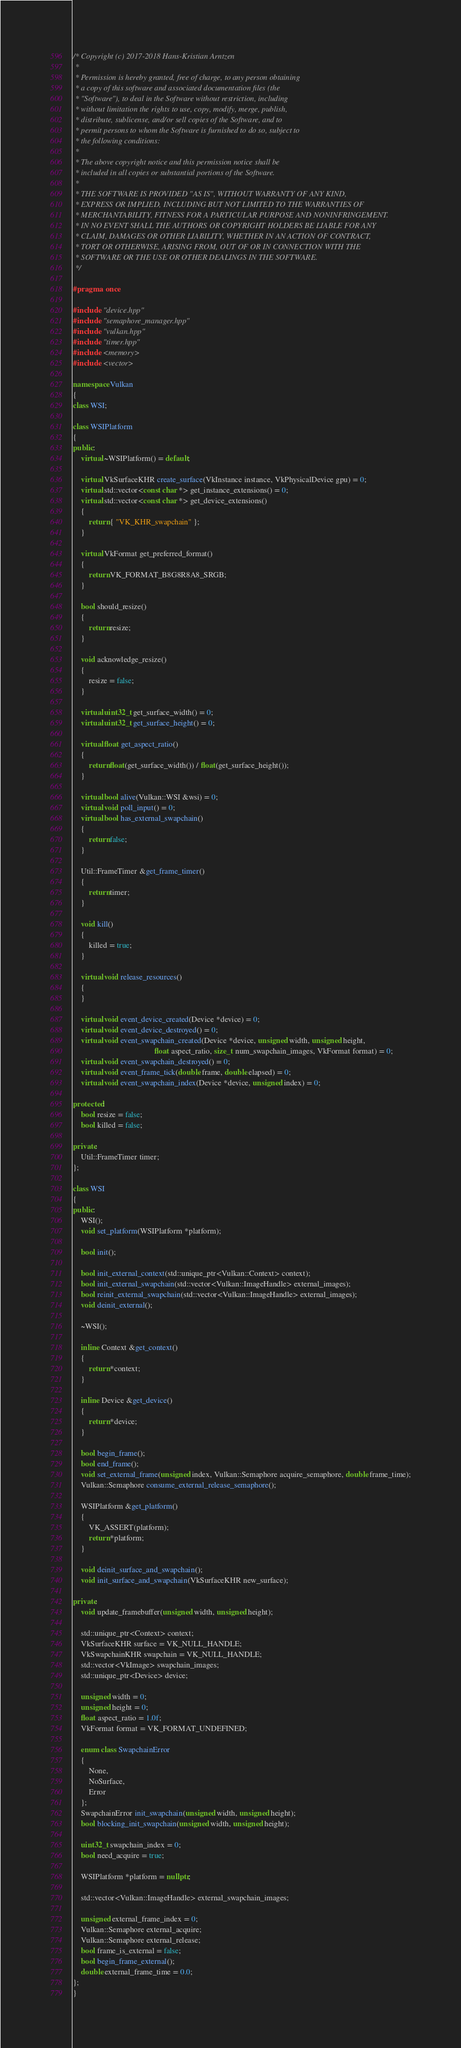<code> <loc_0><loc_0><loc_500><loc_500><_C++_>/* Copyright (c) 2017-2018 Hans-Kristian Arntzen
 *
 * Permission is hereby granted, free of charge, to any person obtaining
 * a copy of this software and associated documentation files (the
 * "Software"), to deal in the Software without restriction, including
 * without limitation the rights to use, copy, modify, merge, publish,
 * distribute, sublicense, and/or sell copies of the Software, and to
 * permit persons to whom the Software is furnished to do so, subject to
 * the following conditions:
 *
 * The above copyright notice and this permission notice shall be
 * included in all copies or substantial portions of the Software.
 *
 * THE SOFTWARE IS PROVIDED "AS IS", WITHOUT WARRANTY OF ANY KIND,
 * EXPRESS OR IMPLIED, INCLUDING BUT NOT LIMITED TO THE WARRANTIES OF
 * MERCHANTABILITY, FITNESS FOR A PARTICULAR PURPOSE AND NONINFRINGEMENT.
 * IN NO EVENT SHALL THE AUTHORS OR COPYRIGHT HOLDERS BE LIABLE FOR ANY
 * CLAIM, DAMAGES OR OTHER LIABILITY, WHETHER IN AN ACTION OF CONTRACT,
 * TORT OR OTHERWISE, ARISING FROM, OUT OF OR IN CONNECTION WITH THE
 * SOFTWARE OR THE USE OR OTHER DEALINGS IN THE SOFTWARE.
 */

#pragma once

#include "device.hpp"
#include "semaphore_manager.hpp"
#include "vulkan.hpp"
#include "timer.hpp"
#include <memory>
#include <vector>

namespace Vulkan
{
class WSI;

class WSIPlatform
{
public:
	virtual ~WSIPlatform() = default;

	virtual VkSurfaceKHR create_surface(VkInstance instance, VkPhysicalDevice gpu) = 0;
	virtual std::vector<const char *> get_instance_extensions() = 0;
	virtual std::vector<const char *> get_device_extensions()
	{
		return { "VK_KHR_swapchain" };
	}

	virtual VkFormat get_preferred_format()
	{
		return VK_FORMAT_B8G8R8A8_SRGB;
	}

	bool should_resize()
	{
		return resize;
	}

	void acknowledge_resize()
	{
		resize = false;
	}

	virtual uint32_t get_surface_width() = 0;
	virtual uint32_t get_surface_height() = 0;

	virtual float get_aspect_ratio()
	{
		return float(get_surface_width()) / float(get_surface_height());
	}

	virtual bool alive(Vulkan::WSI &wsi) = 0;
	virtual void poll_input() = 0;
	virtual bool has_external_swapchain()
	{
		return false;
	}

	Util::FrameTimer &get_frame_timer()
	{
		return timer;
	}

	void kill()
	{
		killed = true;
	}

	virtual void release_resources()
	{
	}

	virtual void event_device_created(Device *device) = 0;
	virtual void event_device_destroyed() = 0;
	virtual void event_swapchain_created(Device *device, unsigned width, unsigned height,
	                                     float aspect_ratio, size_t num_swapchain_images, VkFormat format) = 0;
	virtual void event_swapchain_destroyed() = 0;
	virtual void event_frame_tick(double frame, double elapsed) = 0;
	virtual void event_swapchain_index(Device *device, unsigned index) = 0;

protected:
	bool resize = false;
	bool killed = false;

private:
	Util::FrameTimer timer;
};

class WSI
{
public:
	WSI();
	void set_platform(WSIPlatform *platform);

	bool init();

	bool init_external_context(std::unique_ptr<Vulkan::Context> context);
	bool init_external_swapchain(std::vector<Vulkan::ImageHandle> external_images);
	bool reinit_external_swapchain(std::vector<Vulkan::ImageHandle> external_images);
	void deinit_external();

	~WSI();

	inline Context &get_context()
	{
		return *context;
	}

	inline Device &get_device()
	{
		return *device;
	}

	bool begin_frame();
	bool end_frame();
	void set_external_frame(unsigned index, Vulkan::Semaphore acquire_semaphore, double frame_time);
	Vulkan::Semaphore consume_external_release_semaphore();

	WSIPlatform &get_platform()
	{
		VK_ASSERT(platform);
		return *platform;
	}

	void deinit_surface_and_swapchain();
	void init_surface_and_swapchain(VkSurfaceKHR new_surface);

private:
	void update_framebuffer(unsigned width, unsigned height);

	std::unique_ptr<Context> context;
	VkSurfaceKHR surface = VK_NULL_HANDLE;
	VkSwapchainKHR swapchain = VK_NULL_HANDLE;
	std::vector<VkImage> swapchain_images;
	std::unique_ptr<Device> device;

	unsigned width = 0;
	unsigned height = 0;
	float aspect_ratio = 1.0f;
	VkFormat format = VK_FORMAT_UNDEFINED;

	enum class SwapchainError
	{
		None,
		NoSurface,
		Error
	};
	SwapchainError init_swapchain(unsigned width, unsigned height);
	bool blocking_init_swapchain(unsigned width, unsigned height);

	uint32_t swapchain_index = 0;
	bool need_acquire = true;

	WSIPlatform *platform = nullptr;

	std::vector<Vulkan::ImageHandle> external_swapchain_images;

	unsigned external_frame_index = 0;
	Vulkan::Semaphore external_acquire;
	Vulkan::Semaphore external_release;
	bool frame_is_external = false;
	bool begin_frame_external();
	double external_frame_time = 0.0;
};
}
</code> 